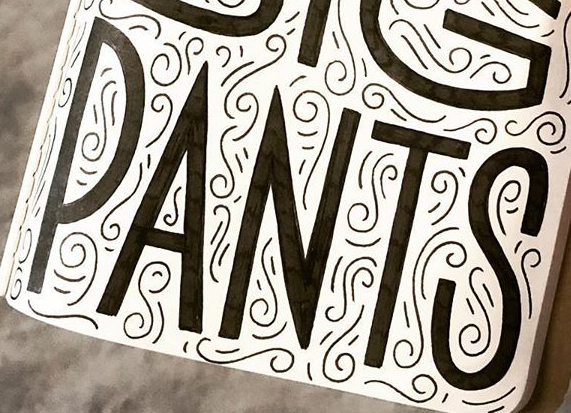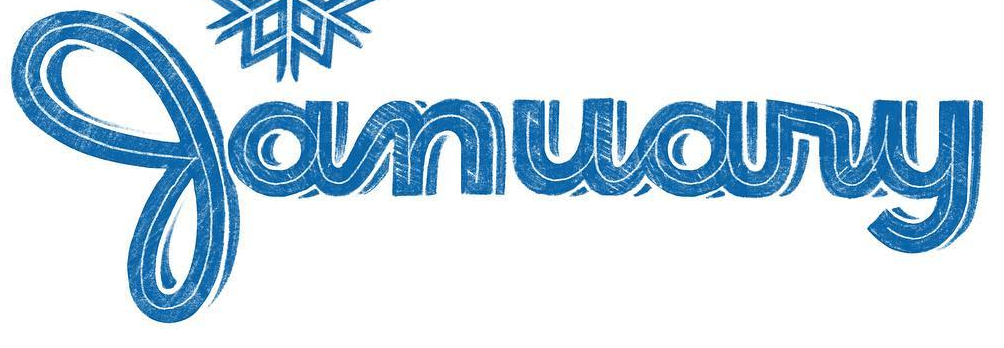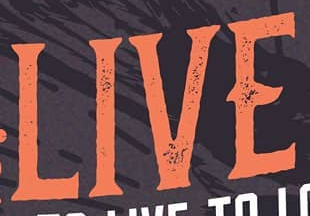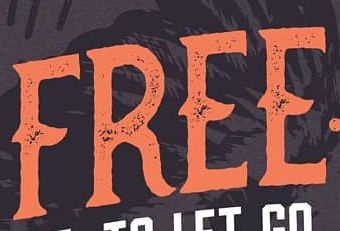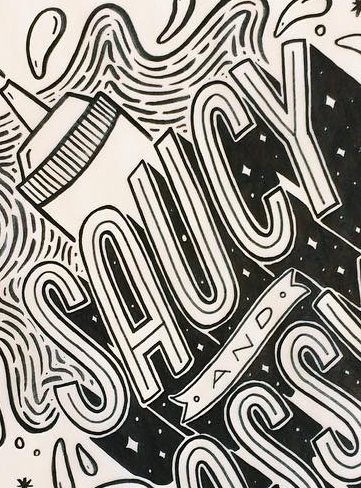What words are shown in these images in order, separated by a semicolon? PANTS; January; LIVE; FREE; SAUCY 